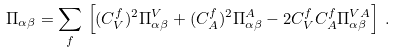Convert formula to latex. <formula><loc_0><loc_0><loc_500><loc_500>\Pi _ { \alpha \beta } = \sum _ { f } \, \left [ ( C _ { V } ^ { f } ) ^ { 2 } \Pi ^ { V } _ { \alpha \beta } + ( C _ { A } ^ { f } ) ^ { 2 } \Pi ^ { A } _ { \alpha \beta } - 2 C _ { V } ^ { f } C _ { A } ^ { f } \Pi ^ { V A } _ { \alpha \beta } \right ] \, .</formula> 